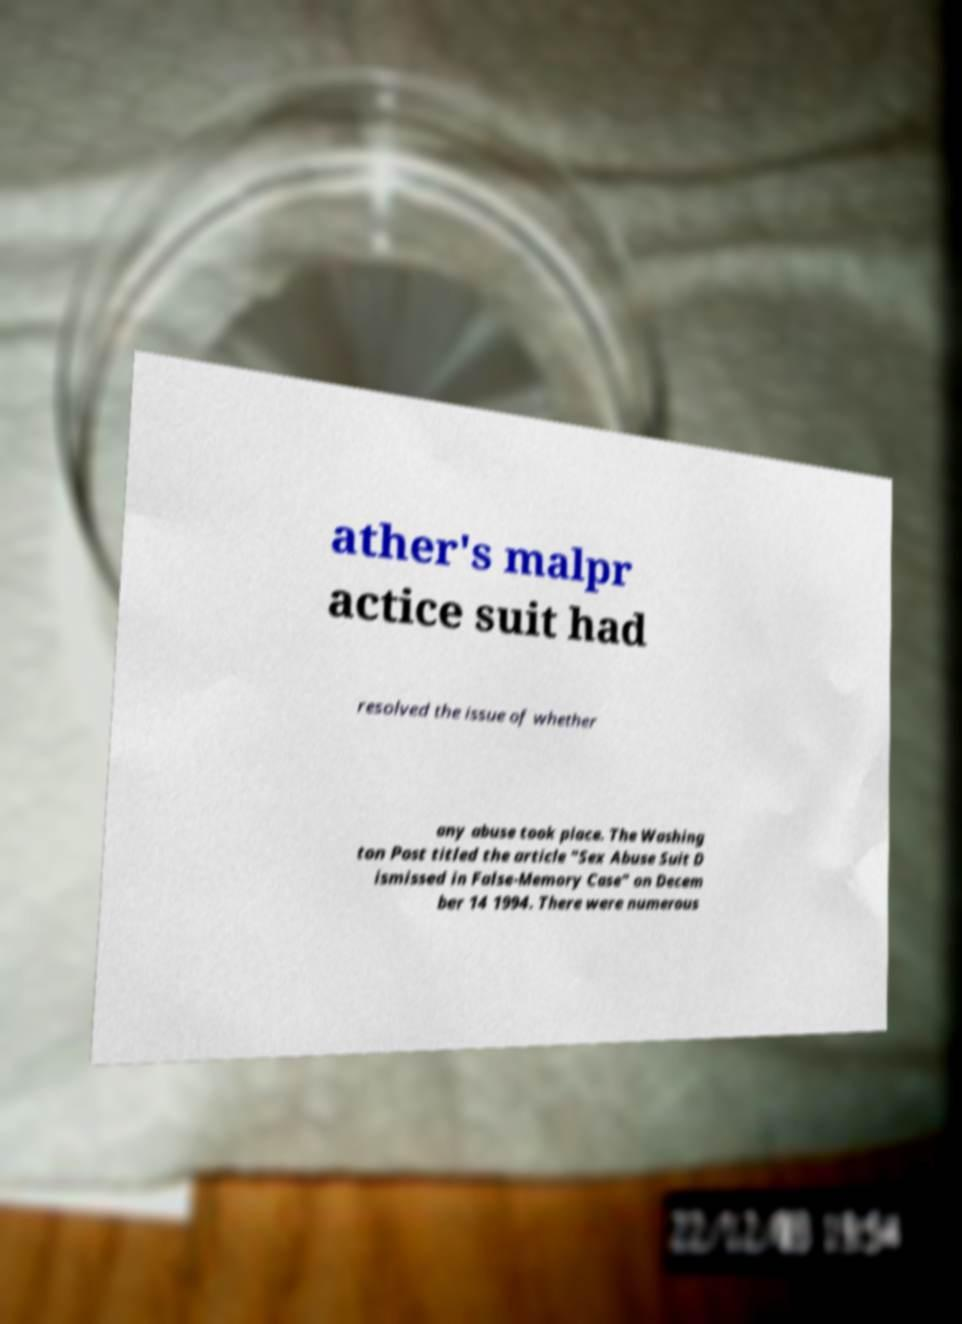Please read and relay the text visible in this image. What does it say? ather's malpr actice suit had resolved the issue of whether any abuse took place. The Washing ton Post titled the article "Sex Abuse Suit D ismissed in False-Memory Case" on Decem ber 14 1994. There were numerous 